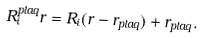Convert formula to latex. <formula><loc_0><loc_0><loc_500><loc_500>R _ { i } ^ { p l a q } r = R _ { i } ( r - r _ { p l a q } ) + r _ { p l a q } .</formula> 